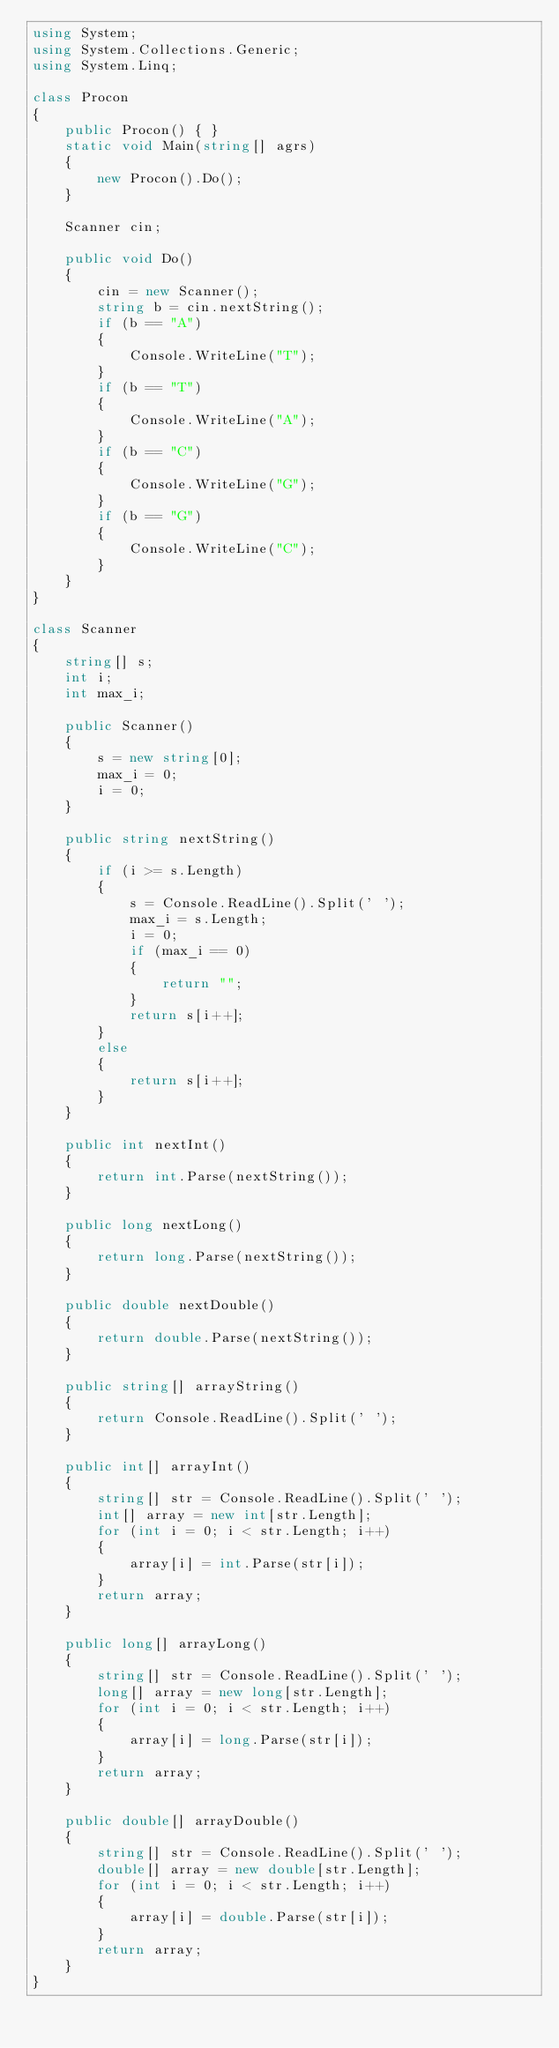Convert code to text. <code><loc_0><loc_0><loc_500><loc_500><_C#_>using System;
using System.Collections.Generic;
using System.Linq;

class Procon
{
    public Procon() { }
    static void Main(string[] agrs)
    {
        new Procon().Do();
    }

    Scanner cin;

    public void Do()
    {
        cin = new Scanner();
        string b = cin.nextString();
        if (b == "A")
        {
            Console.WriteLine("T");
        }
        if (b == "T")
        {
            Console.WriteLine("A");
        }
        if (b == "C")
        {
            Console.WriteLine("G");
        }
        if (b == "G")
        {
            Console.WriteLine("C");
        }
    }
}

class Scanner
{
    string[] s;
    int i;
    int max_i;

    public Scanner()
    {
        s = new string[0];
        max_i = 0;
        i = 0;
    }

    public string nextString()
    {
        if (i >= s.Length)
        {
            s = Console.ReadLine().Split(' ');
            max_i = s.Length;
            i = 0;
            if (max_i == 0)
            {
                return "";
            }
            return s[i++];
        }
        else
        {
            return s[i++];
        }
    }

    public int nextInt()
    {
        return int.Parse(nextString());
    }

    public long nextLong()
    {
        return long.Parse(nextString());
    }

    public double nextDouble()
    {
        return double.Parse(nextString());
    }

    public string[] arrayString()
    {
        return Console.ReadLine().Split(' ');
    }

    public int[] arrayInt()
    {
        string[] str = Console.ReadLine().Split(' ');
        int[] array = new int[str.Length];
        for (int i = 0; i < str.Length; i++)
        {
            array[i] = int.Parse(str[i]);
        }
        return array;
    }

    public long[] arrayLong()
    {
        string[] str = Console.ReadLine().Split(' ');
        long[] array = new long[str.Length];
        for (int i = 0; i < str.Length; i++)
        {
            array[i] = long.Parse(str[i]);
        }
        return array;
    }

    public double[] arrayDouble()
    {
        string[] str = Console.ReadLine().Split(' ');
        double[] array = new double[str.Length];
        for (int i = 0; i < str.Length; i++)
        {
            array[i] = double.Parse(str[i]);
        }
        return array;
    }
}</code> 